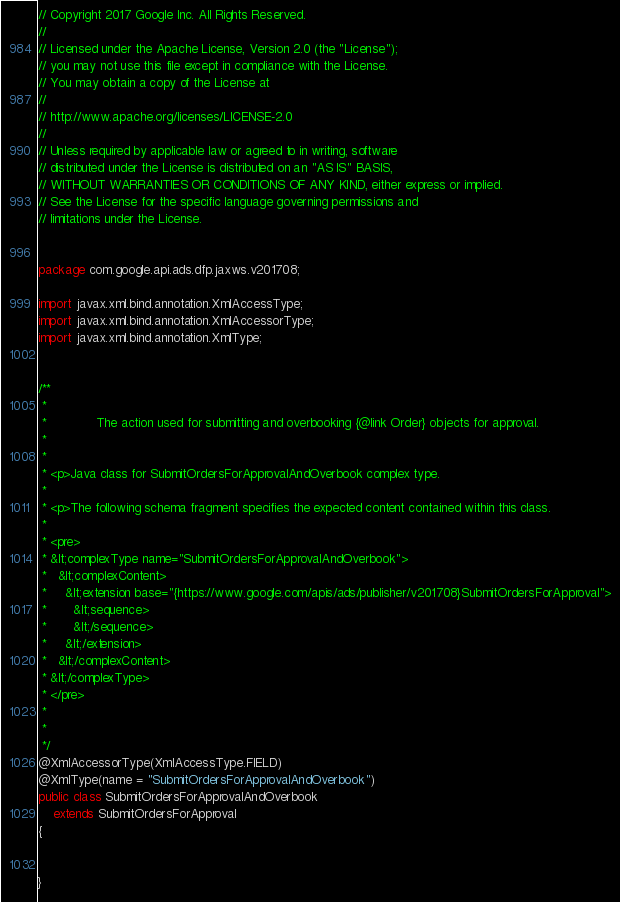<code> <loc_0><loc_0><loc_500><loc_500><_Java_>// Copyright 2017 Google Inc. All Rights Reserved.
//
// Licensed under the Apache License, Version 2.0 (the "License");
// you may not use this file except in compliance with the License.
// You may obtain a copy of the License at
//
// http://www.apache.org/licenses/LICENSE-2.0
//
// Unless required by applicable law or agreed to in writing, software
// distributed under the License is distributed on an "AS IS" BASIS,
// WITHOUT WARRANTIES OR CONDITIONS OF ANY KIND, either express or implied.
// See the License for the specific language governing permissions and
// limitations under the License.


package com.google.api.ads.dfp.jaxws.v201708;

import javax.xml.bind.annotation.XmlAccessType;
import javax.xml.bind.annotation.XmlAccessorType;
import javax.xml.bind.annotation.XmlType;


/**
 * 
 *             The action used for submitting and overbooking {@link Order} objects for approval.
 *           
 * 
 * <p>Java class for SubmitOrdersForApprovalAndOverbook complex type.
 * 
 * <p>The following schema fragment specifies the expected content contained within this class.
 * 
 * <pre>
 * &lt;complexType name="SubmitOrdersForApprovalAndOverbook">
 *   &lt;complexContent>
 *     &lt;extension base="{https://www.google.com/apis/ads/publisher/v201708}SubmitOrdersForApproval">
 *       &lt;sequence>
 *       &lt;/sequence>
 *     &lt;/extension>
 *   &lt;/complexContent>
 * &lt;/complexType>
 * </pre>
 * 
 * 
 */
@XmlAccessorType(XmlAccessType.FIELD)
@XmlType(name = "SubmitOrdersForApprovalAndOverbook")
public class SubmitOrdersForApprovalAndOverbook
    extends SubmitOrdersForApproval
{


}
</code> 